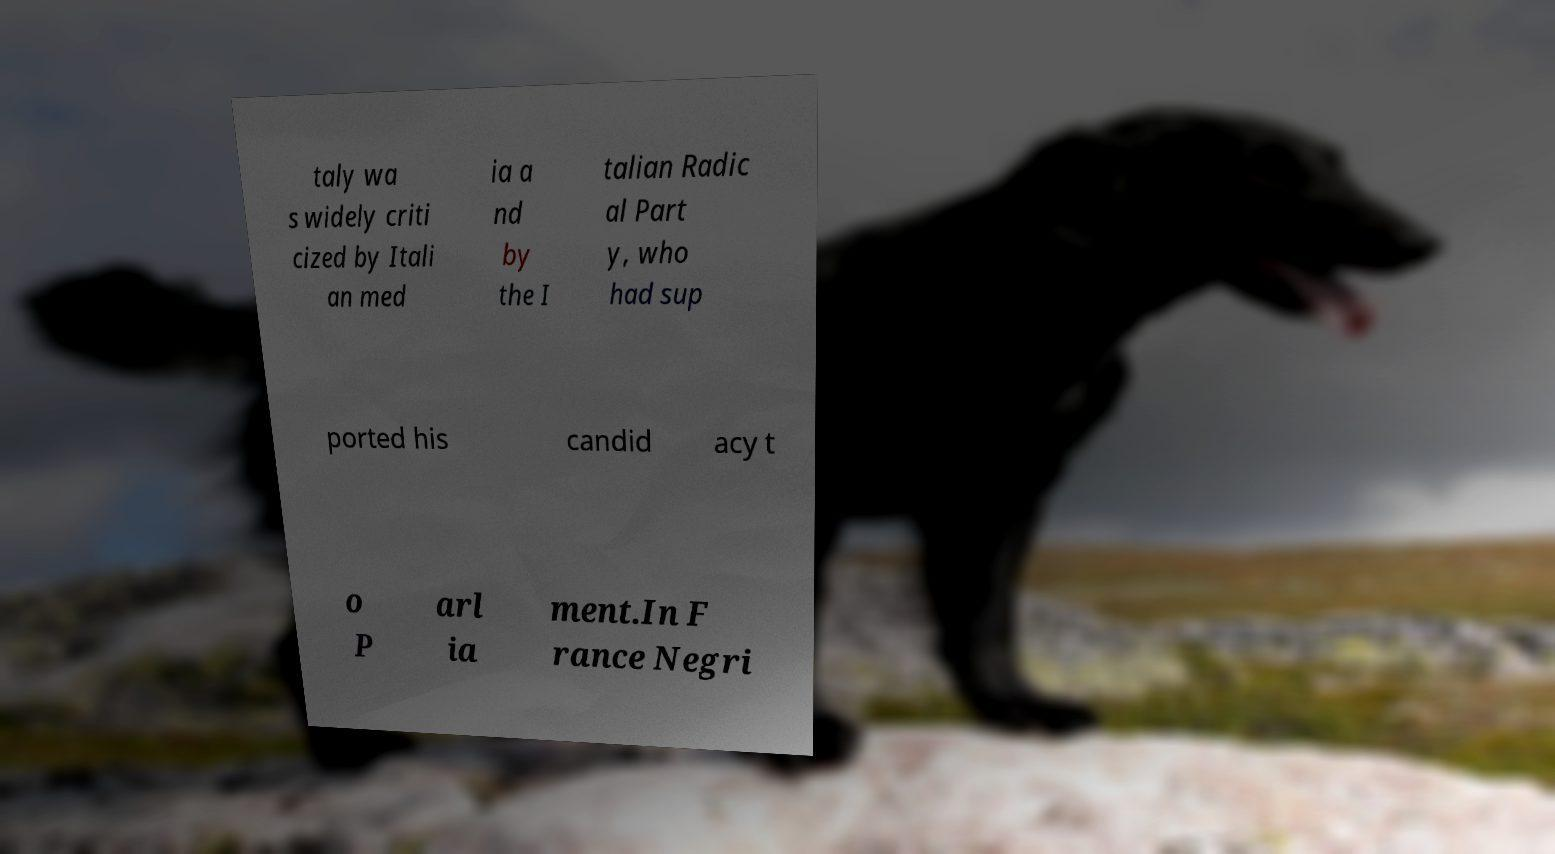For documentation purposes, I need the text within this image transcribed. Could you provide that? taly wa s widely criti cized by Itali an med ia a nd by the I talian Radic al Part y, who had sup ported his candid acy t o P arl ia ment.In F rance Negri 